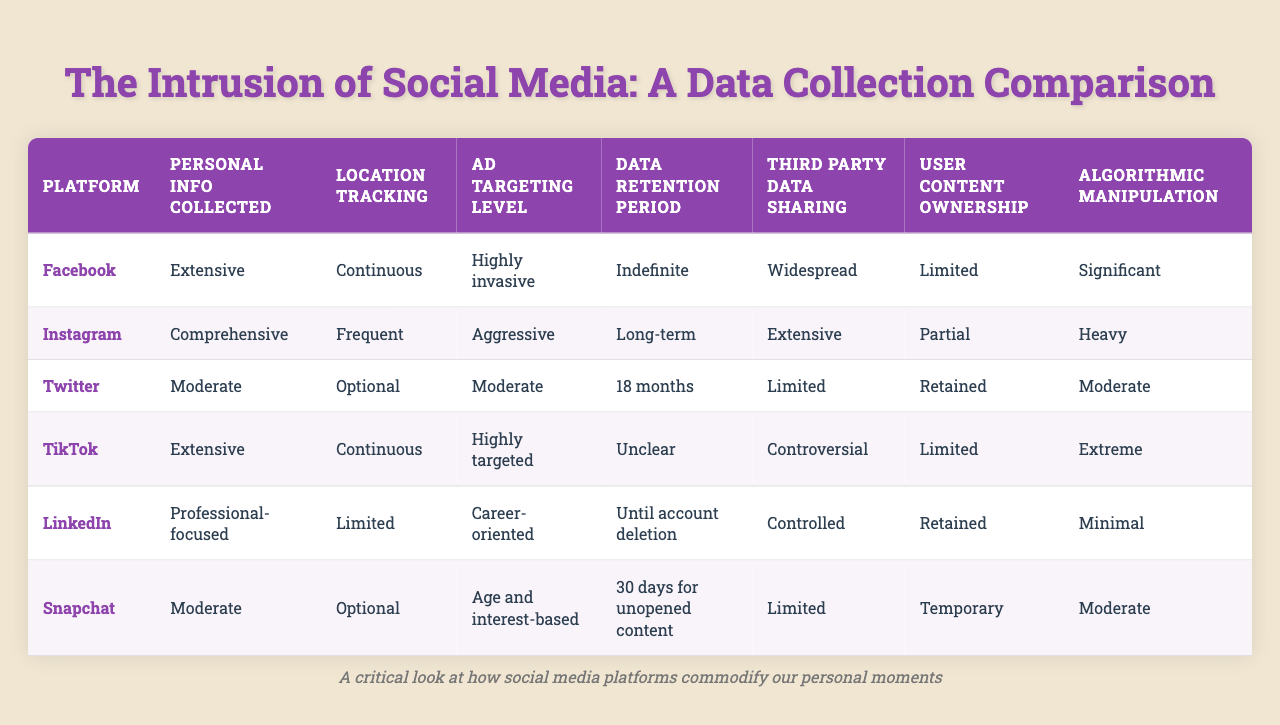What social media platform has the most extensive personal information collection? According to the table, both Facebook and TikTok have "Extensive" personal information collected, but the question specifies the most extensive. Therefore, we focus on Facebook since it is mentioned first and is known for its wide-ranging collection practices.
Answer: Facebook Which platform has the longest data retention period? The data retention period for Facebook is "Indefinite," while Instagram is "Long-term," Twitter is "18 months," TikTok is "Unclear," LinkedIn keeps data "Until account deletion," and Snapchat retains content for "30 days for unopened content." Since "Indefinite" is the longest duration, the answer is Facebook.
Answer: Facebook Does Twitter share data with third parties? The table indicates that Twitter's third-party data sharing is "Limited." Therefore, the answer is **Yes**, as it does share data, albeit in a restricted manner.
Answer: Yes How does Instagram's ad targeting level compare to Twitter? Instagram's ad targeting level is "Aggressive," while Twitter's is "Moderate." "Aggressive" is higher than "Moderate," indicating that Instagram's approach is more intense in this regard.
Answer: Instagram Which platform offers the most user content ownership? The table states that LinkedIn and Twitter both have content ownership classified as "Retained," and only like Snapchat has "Temporary," while Snapchat has "Limited." Therefore, LinkedIn and Twitter offer the most user content ownership.
Answer: LinkedIn and Twitter What is the difference in location tracking between Facebook and Snapchat? Facebook has "Continuous" location tracking, while Snapchat has "Optional." This means Facebook constantly tracks the user's location, while Snapchat allows the user to choose whether to share their location. Thus, the difference is one tracks continuously, and the other permits user discretion.
Answer: Continuous vs. Optional Which platforms have highly invasive ad targeting levels? The table shows that Facebook has "Highly invasive," TikTok has "Highly targeted," and Instagram has "Aggressive." Since "Highly invasive" is the most intense targeting, it includes Facebook and follows with TikTok.
Answer: Facebook and TikTok Identify the platform with the least algorithmic manipulation. The table indicates that LinkedIn has "Minimal" algorithmic manipulation, indicating this is the least compared to others like Facebook or TikTok, which have higher levels of manipulation.
Answer: LinkedIn Explain how data retention policies differ between LinkedIn and Snapchat. LinkedIn retains data "Until account deletion," meaning users can keep their data until they choose to delete their accounts. In contrast, Snapchat retains content only "30 days for unopened content," which means if users don’t open it in this timeframe, it's removed. This shows LinkedIn's policy allows for a permanent record, whereas Snapchat has a much shorter timeframe.
Answer: LinkedIn offers longer retention until deletion, while Snapchat has 30 days for unopened content Which platform has significant algorithmic manipulation, and why is it a concern? Facebook has "Significant," Instagram has "Heavy," and TikTok has "Extreme." This is concerning as high levels of algorithmic manipulation can impact user experience, shape content visibility, and may lead to echo chambers or misinformation.
Answer: TikTok 